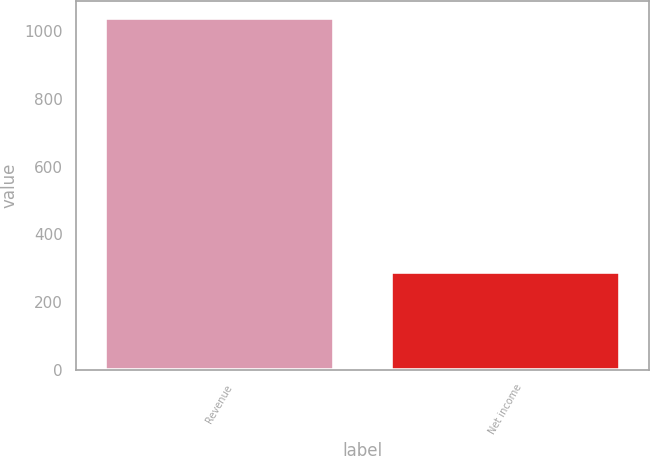Convert chart. <chart><loc_0><loc_0><loc_500><loc_500><bar_chart><fcel>Revenue<fcel>Net income<nl><fcel>1038.4<fcel>288<nl></chart> 